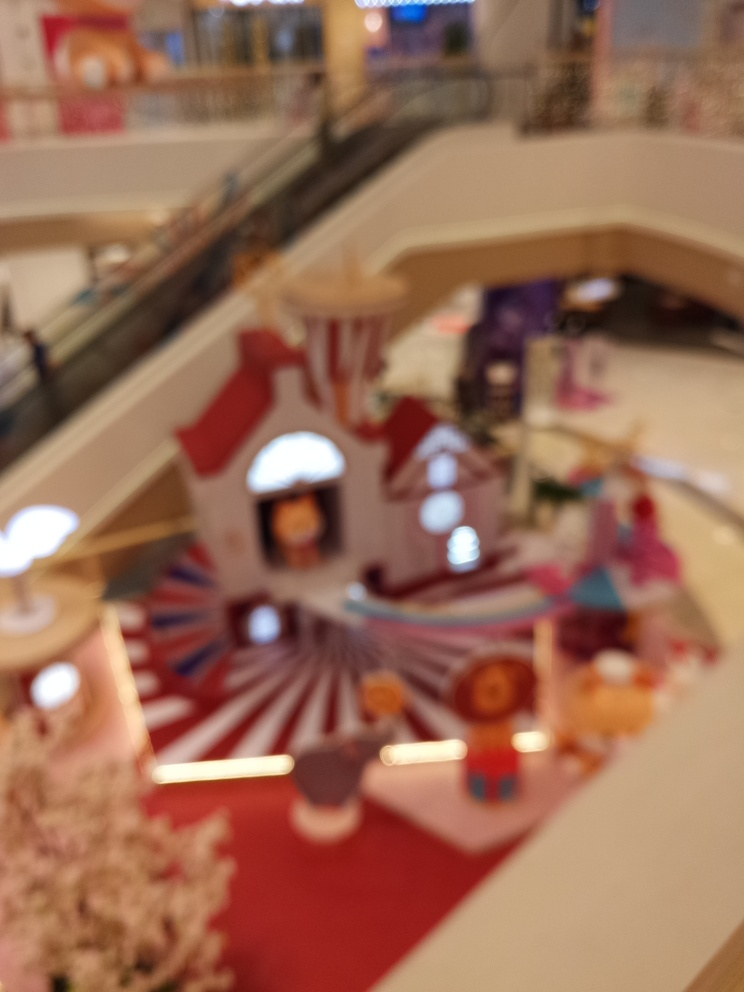What time of day do you think it is in this location, and why? Although the image is blurry and lacks detail, the absence of shadows and even lighting suggests that it might be daytime with artificial lighting. However, without clearer visual cues or windows visible in the image, it's difficult to determine the exact time of day with certainty. 